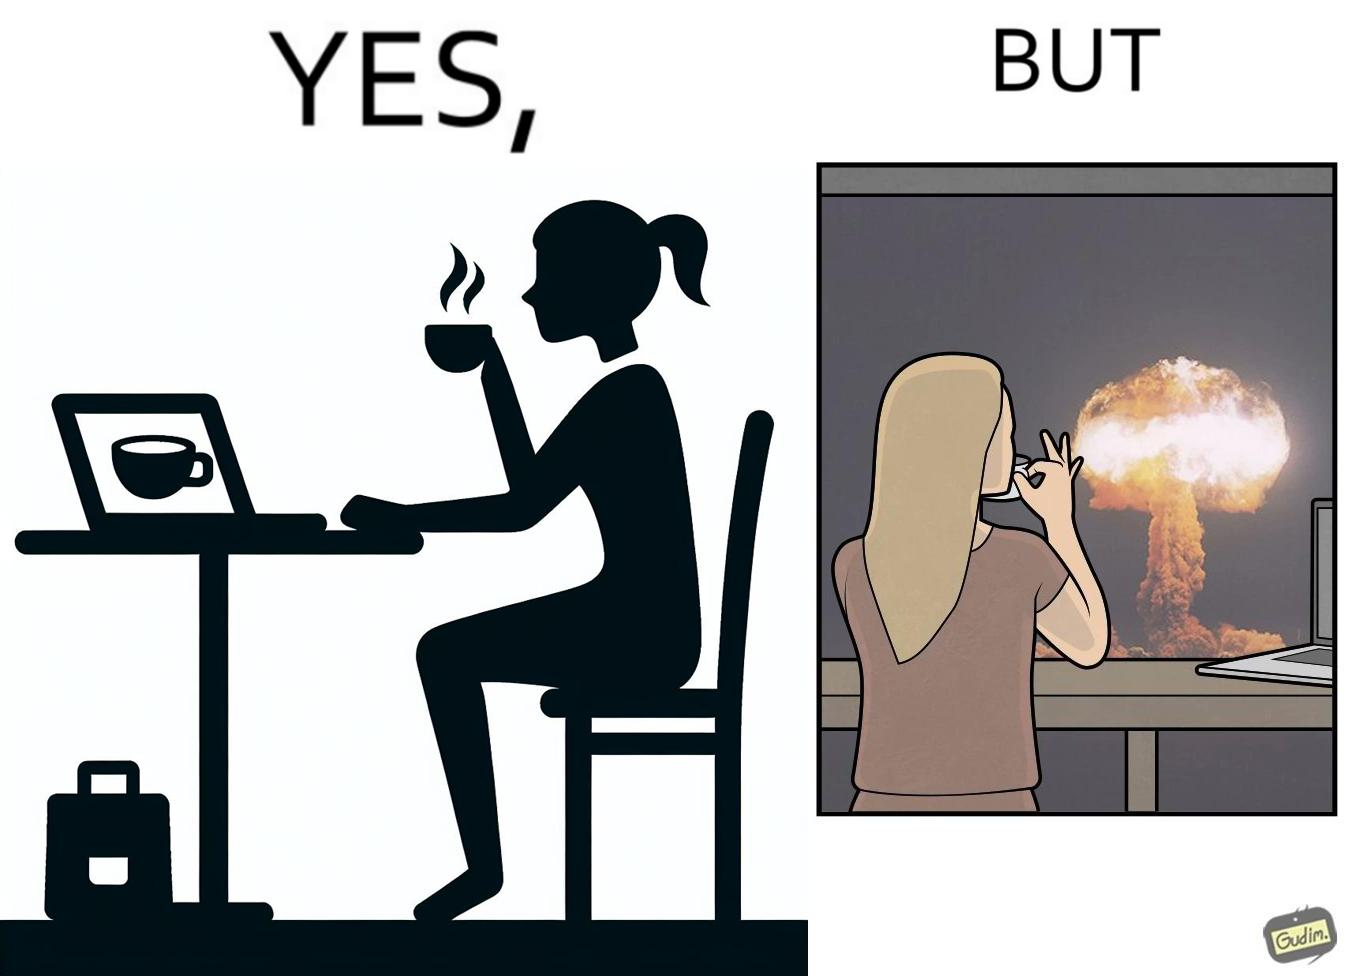What is shown in the left half versus the right half of this image? In the left part of the image: A woman sipping from a cup in a cafe with her laptop In the right part of the image: A woman sipping from a cup while looking at a nuclear blast from her desk 